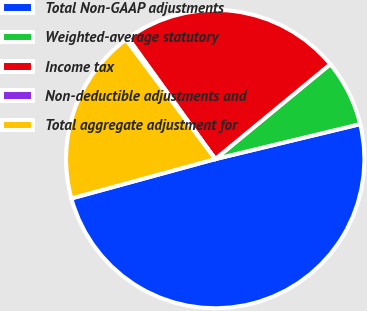Convert chart to OTSL. <chart><loc_0><loc_0><loc_500><loc_500><pie_chart><fcel>Total Non-GAAP adjustments<fcel>Weighted-average statutory<fcel>Income tax<fcel>Non-deductible adjustments and<fcel>Total aggregate adjustment for<nl><fcel>49.52%<fcel>7.21%<fcel>23.96%<fcel>0.28%<fcel>19.03%<nl></chart> 